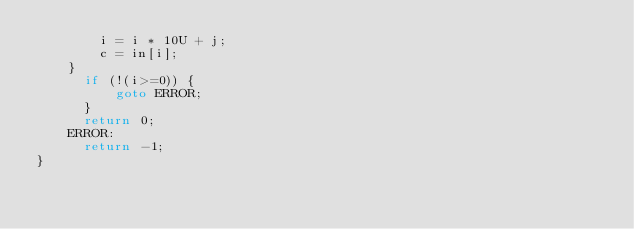<code> <loc_0><loc_0><loc_500><loc_500><_C_>        i = i * 10U + j;
        c = in[i];
    }
      if (!(i>=0)) {
          goto ERROR;
      }
      return 0;
    ERROR:
      return -1;
}
</code> 